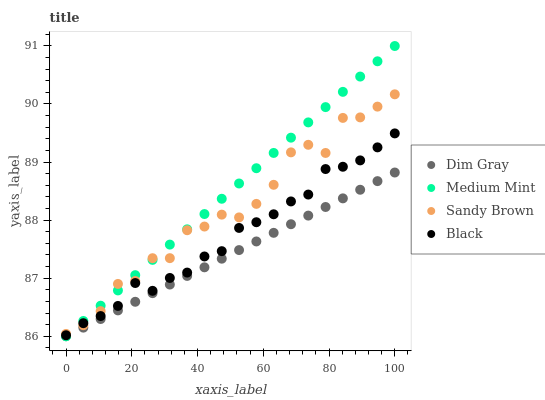Does Dim Gray have the minimum area under the curve?
Answer yes or no. Yes. Does Medium Mint have the maximum area under the curve?
Answer yes or no. Yes. Does Black have the minimum area under the curve?
Answer yes or no. No. Does Black have the maximum area under the curve?
Answer yes or no. No. Is Medium Mint the smoothest?
Answer yes or no. Yes. Is Sandy Brown the roughest?
Answer yes or no. Yes. Is Black the smoothest?
Answer yes or no. No. Is Black the roughest?
Answer yes or no. No. Does Medium Mint have the lowest value?
Answer yes or no. Yes. Does Black have the lowest value?
Answer yes or no. No. Does Medium Mint have the highest value?
Answer yes or no. Yes. Does Black have the highest value?
Answer yes or no. No. Is Dim Gray less than Black?
Answer yes or no. Yes. Is Sandy Brown greater than Dim Gray?
Answer yes or no. Yes. Does Medium Mint intersect Dim Gray?
Answer yes or no. Yes. Is Medium Mint less than Dim Gray?
Answer yes or no. No. Is Medium Mint greater than Dim Gray?
Answer yes or no. No. Does Dim Gray intersect Black?
Answer yes or no. No. 